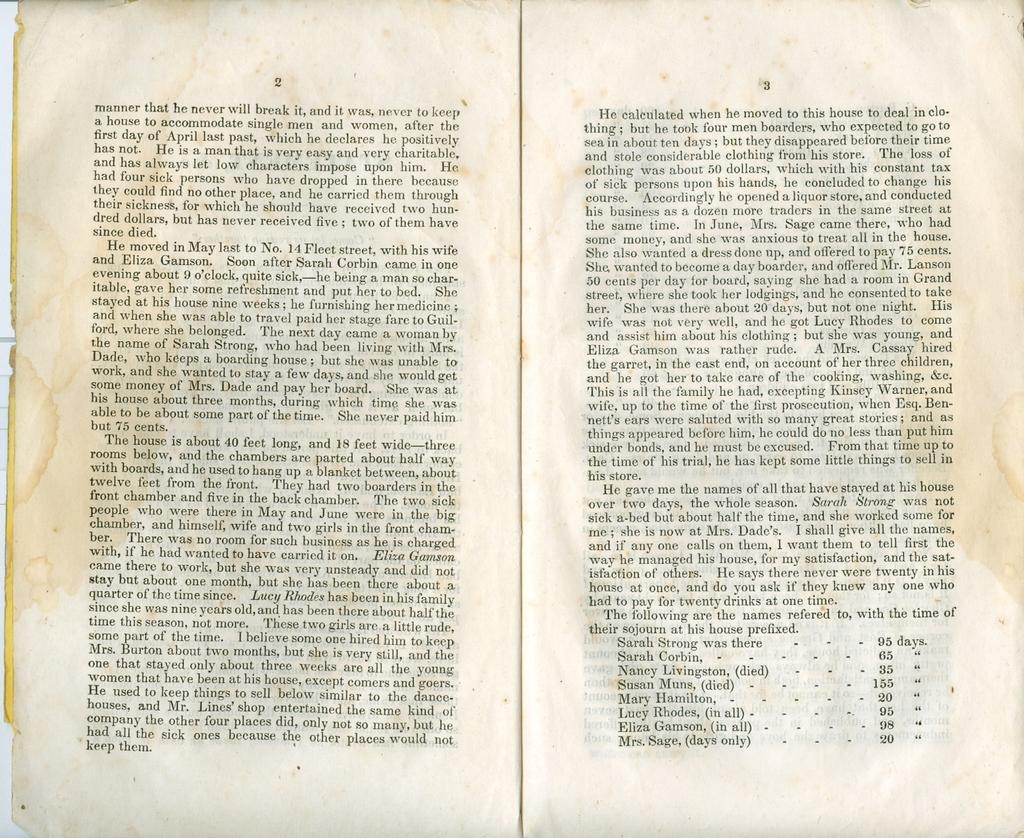Provide a one-sentence caption for the provided image. A book is opened to a page that starts with the word manner. 